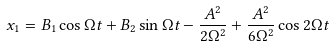<formula> <loc_0><loc_0><loc_500><loc_500>x _ { 1 } = B _ { 1 } \cos { \Omega t } + B _ { 2 } \sin { \Omega t } - \frac { A ^ { 2 } } { 2 \Omega ^ { 2 } } + \frac { A ^ { 2 } } { 6 \Omega ^ { 2 } } \cos { 2 \Omega t }</formula> 